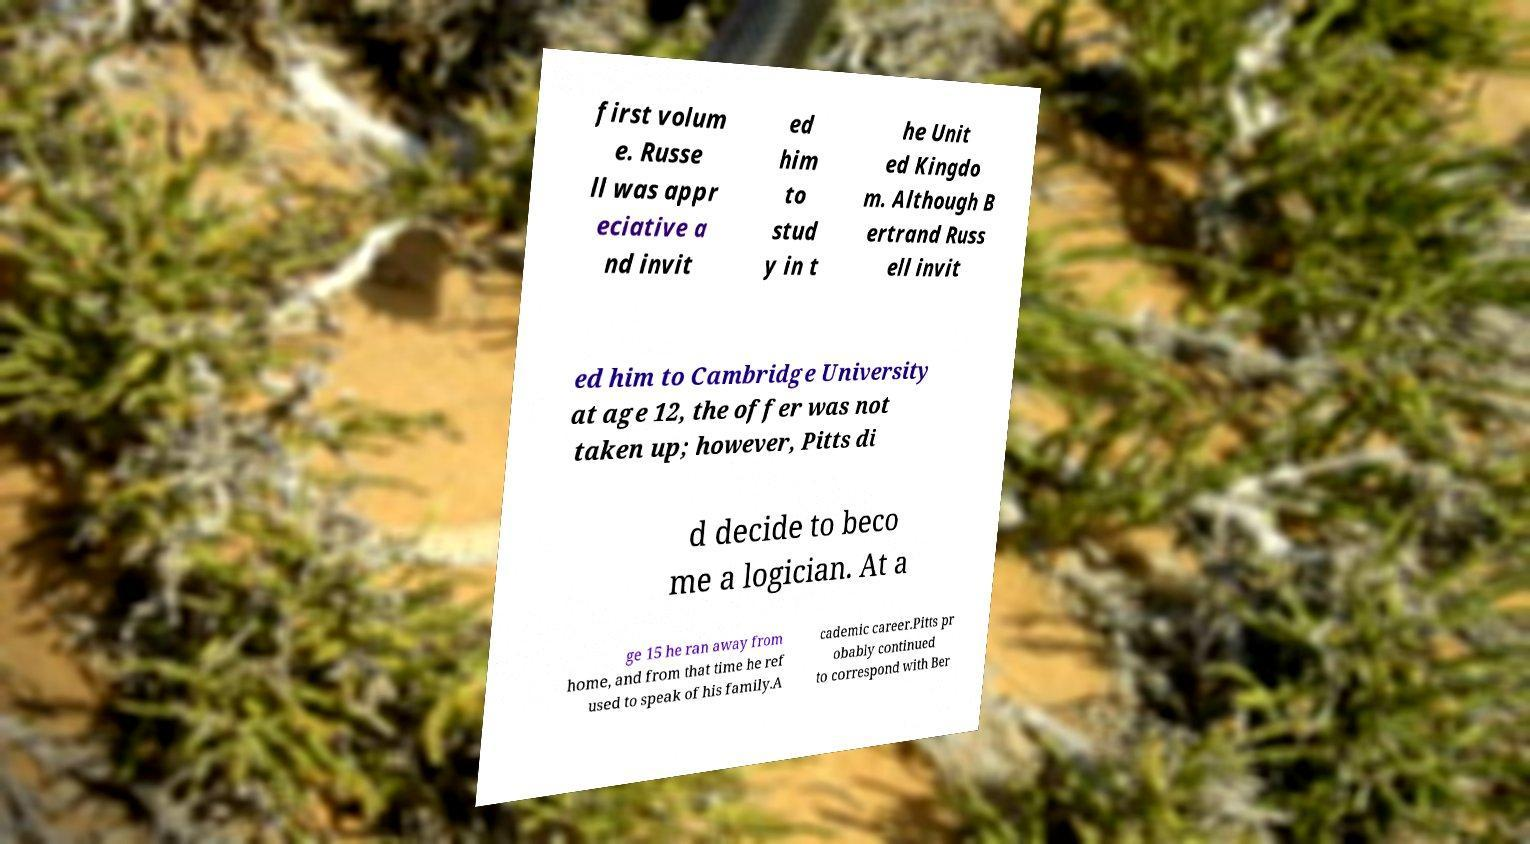Please identify and transcribe the text found in this image. first volum e. Russe ll was appr eciative a nd invit ed him to stud y in t he Unit ed Kingdo m. Although B ertrand Russ ell invit ed him to Cambridge University at age 12, the offer was not taken up; however, Pitts di d decide to beco me a logician. At a ge 15 he ran away from home, and from that time he ref used to speak of his family.A cademic career.Pitts pr obably continued to correspond with Ber 